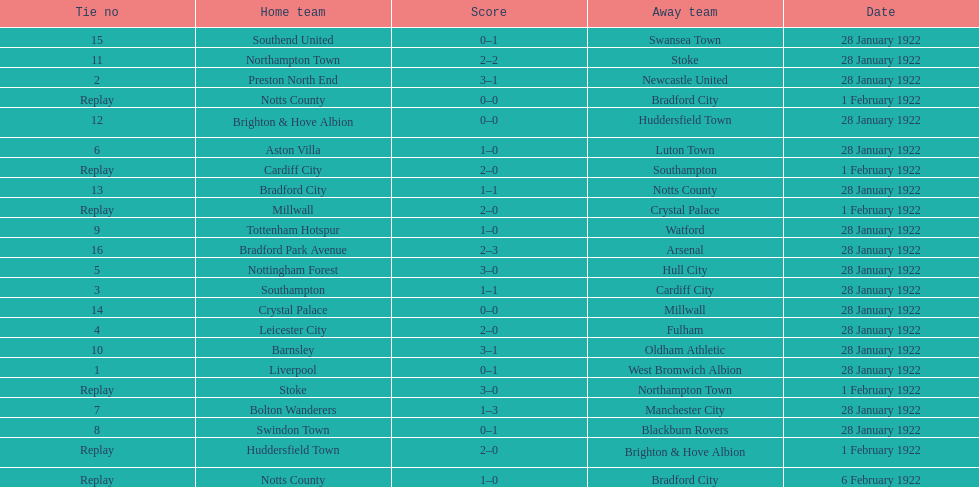Who is the first home team listed as having a score of 3-1? Preston North End. 